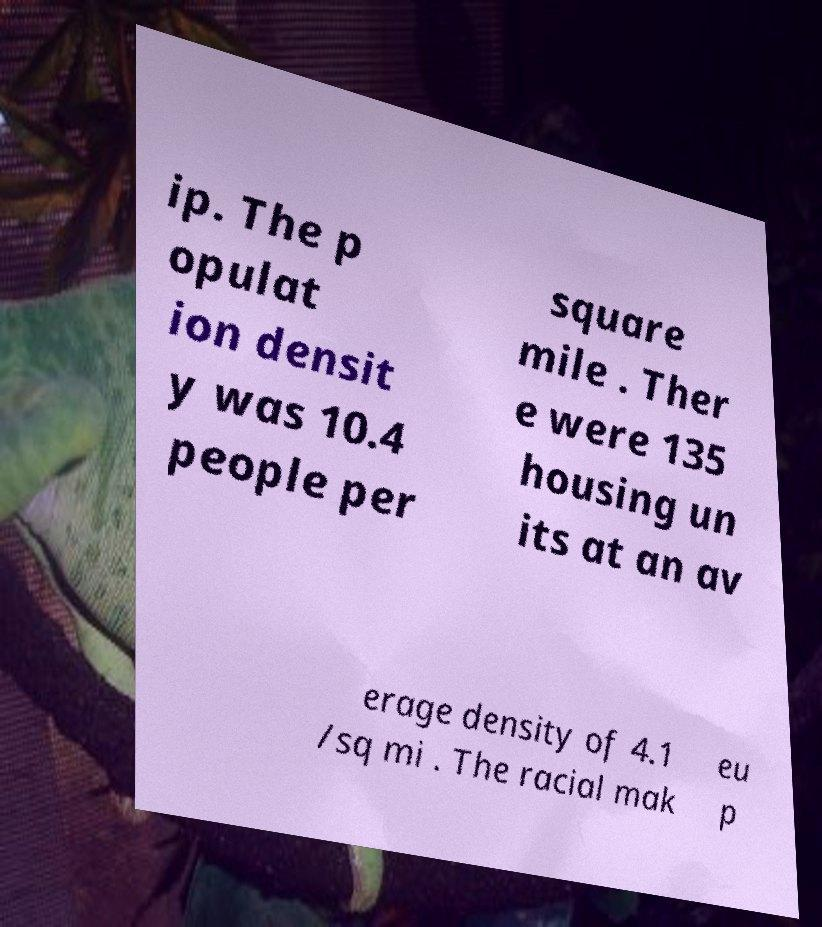Could you assist in decoding the text presented in this image and type it out clearly? ip. The p opulat ion densit y was 10.4 people per square mile . Ther e were 135 housing un its at an av erage density of 4.1 /sq mi . The racial mak eu p 